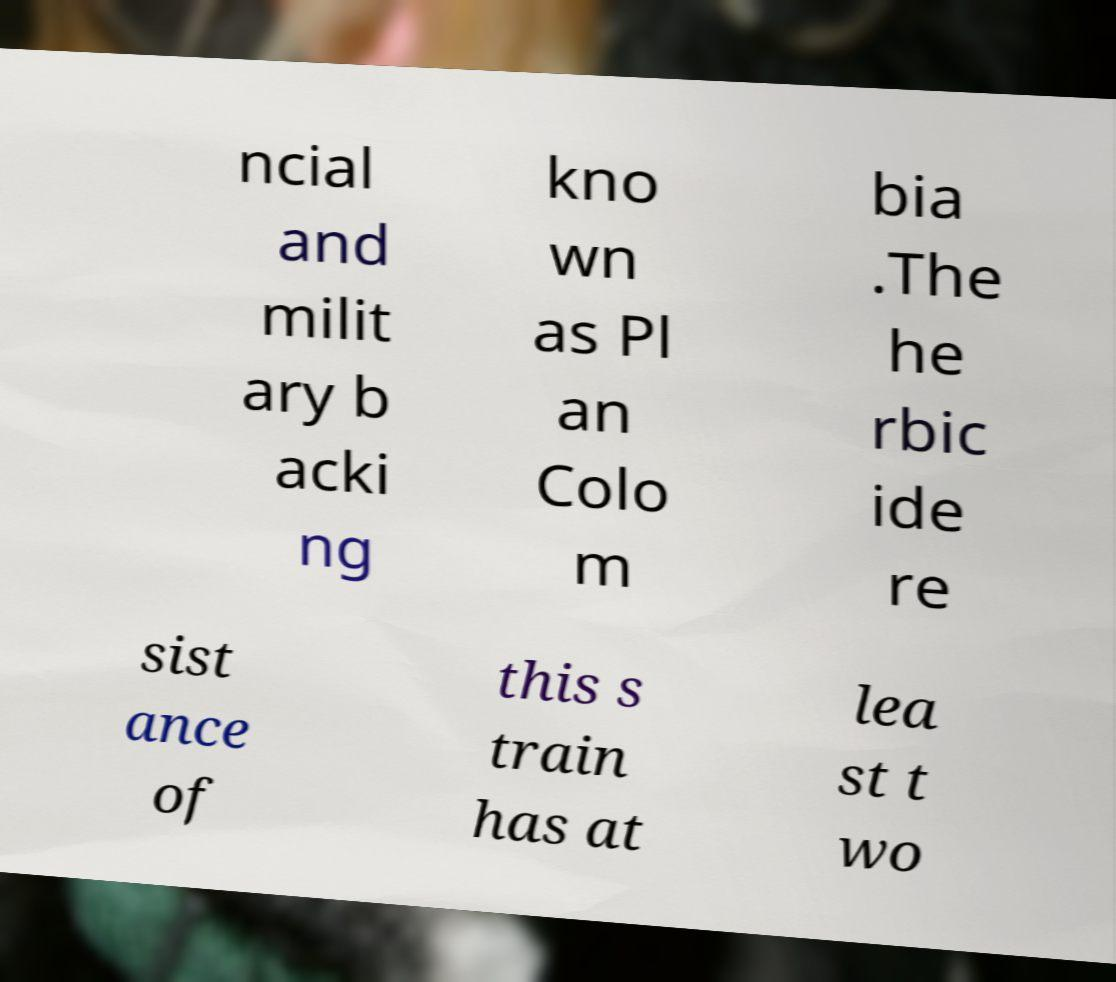I need the written content from this picture converted into text. Can you do that? ncial and milit ary b acki ng kno wn as Pl an Colo m bia .The he rbic ide re sist ance of this s train has at lea st t wo 